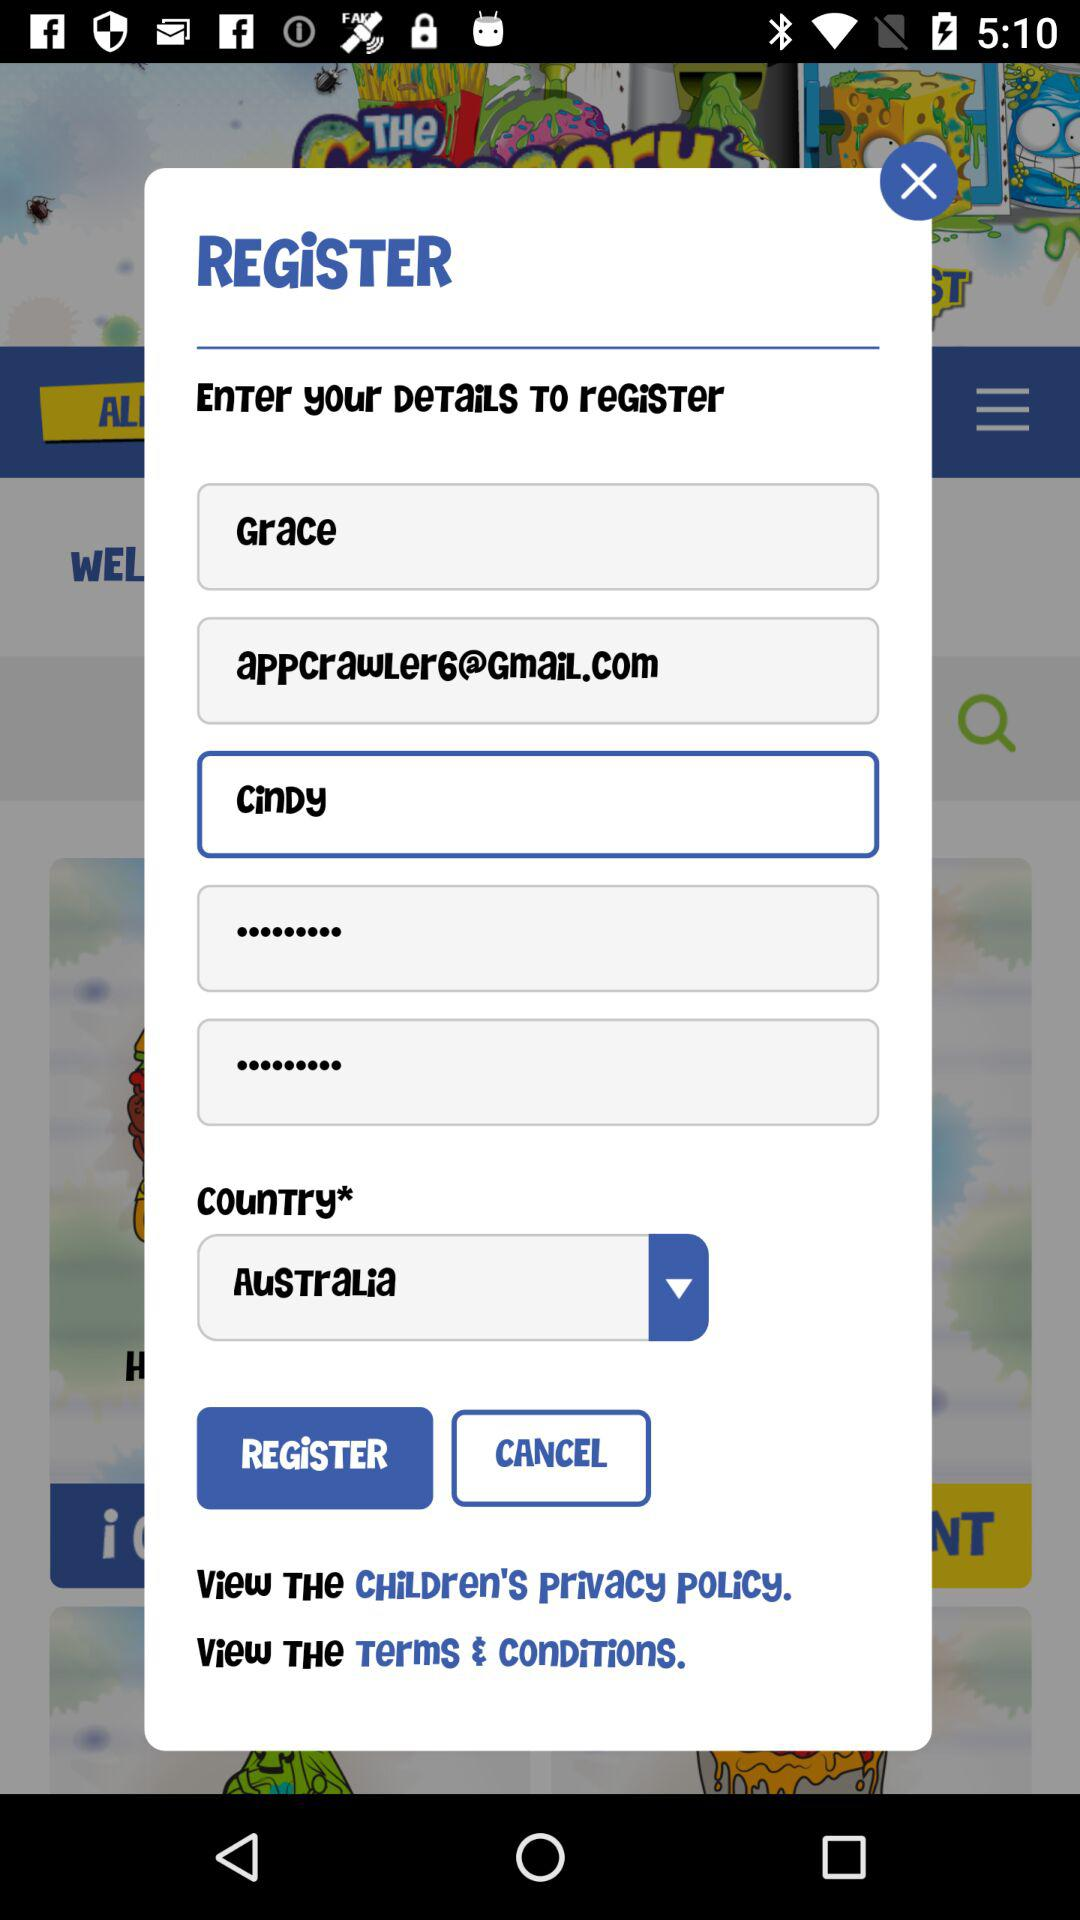Which country is selected? The selected country is Australia. 